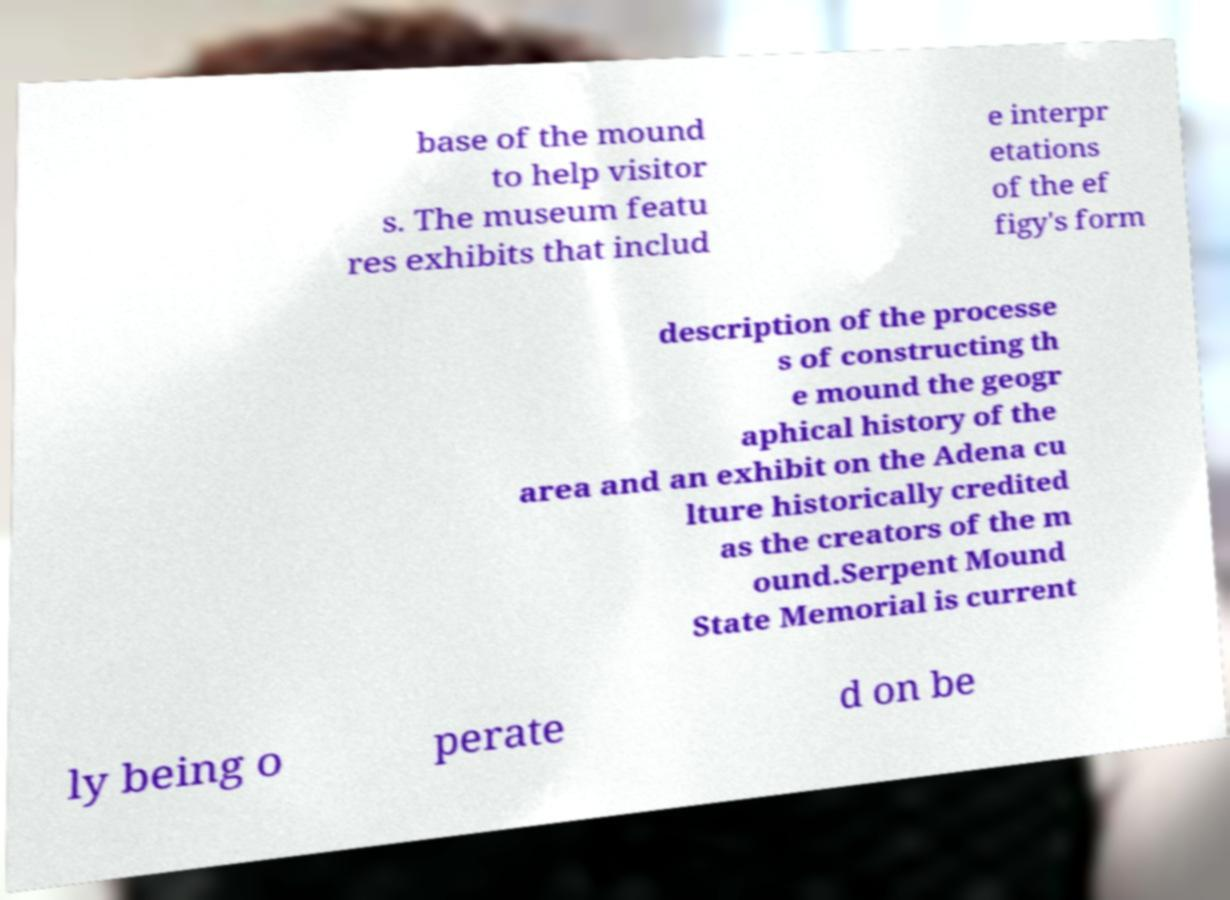Can you read and provide the text displayed in the image?This photo seems to have some interesting text. Can you extract and type it out for me? base of the mound to help visitor s. The museum featu res exhibits that includ e interpr etations of the ef figy's form description of the processe s of constructing th e mound the geogr aphical history of the area and an exhibit on the Adena cu lture historically credited as the creators of the m ound.Serpent Mound State Memorial is current ly being o perate d on be 